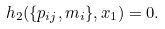<formula> <loc_0><loc_0><loc_500><loc_500>h _ { 2 } ( \{ p _ { i j } , m _ { i } \} , x _ { 1 } ) = 0 .</formula> 